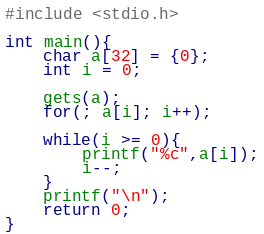<code> <loc_0><loc_0><loc_500><loc_500><_C_>#include <stdio.h>

int main(){
	char a[32] = {0};
	int i = 0;

	gets(a);
	for(; a[i]; i++);

	while(i >= 0){
		printf("%c",a[i]);
		i--;
	}
	printf("\n");
	return 0;
}</code> 